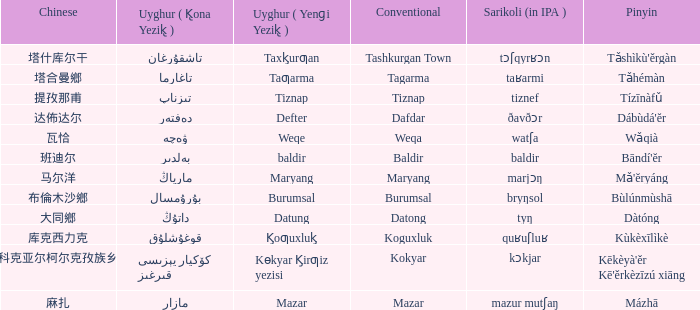Name the conventional for تاغارما Tagarma. 